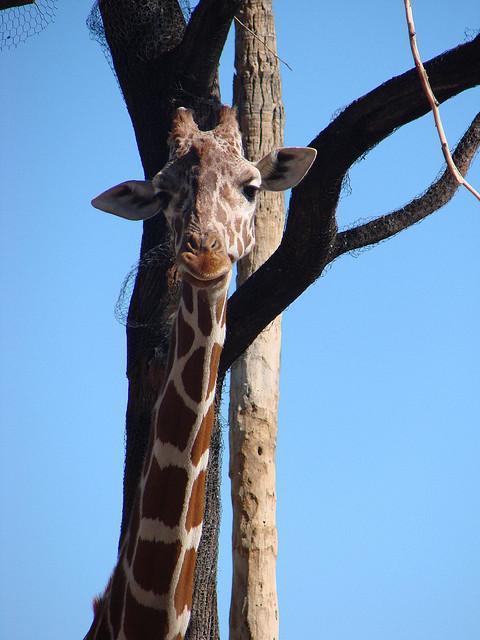How many people are wearing hats?
Give a very brief answer. 0. 